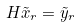<formula> <loc_0><loc_0><loc_500><loc_500>H \tilde { x } _ { r } = \tilde { y } _ { r }</formula> 